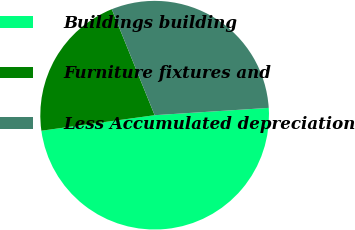Convert chart. <chart><loc_0><loc_0><loc_500><loc_500><pie_chart><fcel>Buildings building<fcel>Furniture fixtures and<fcel>Less Accumulated depreciation<nl><fcel>48.85%<fcel>21.05%<fcel>30.1%<nl></chart> 